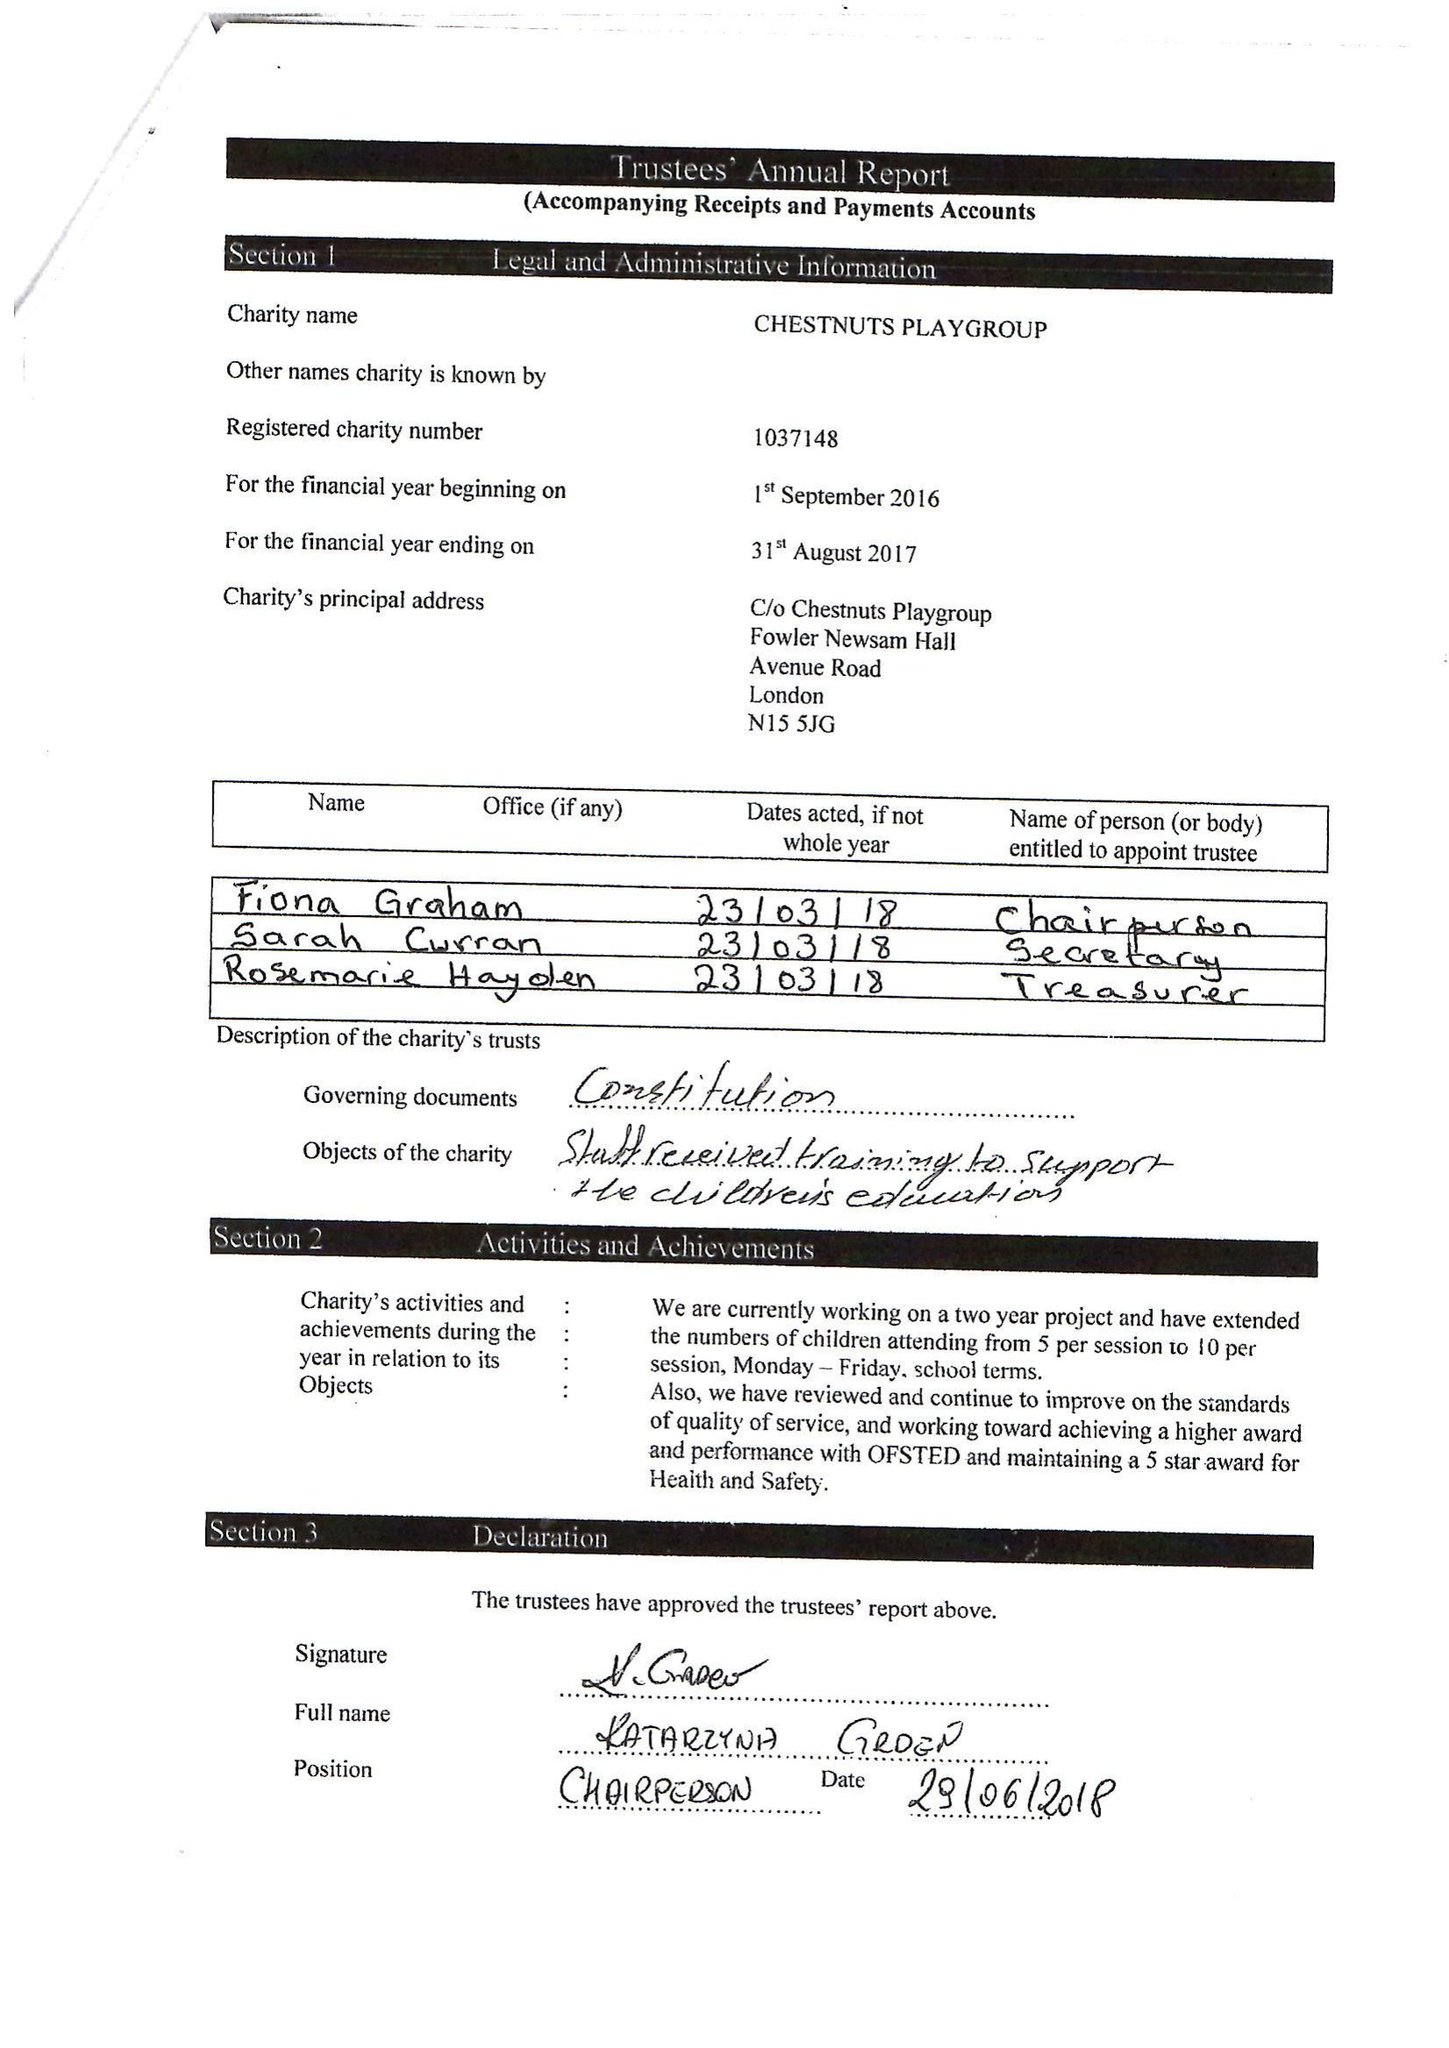What is the value for the address__post_town?
Answer the question using a single word or phrase. LONDON 